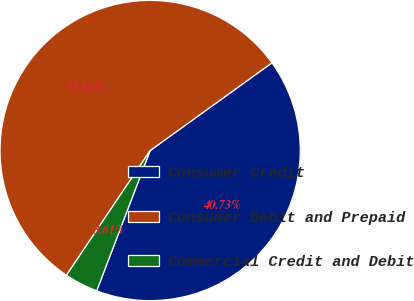Convert chart to OTSL. <chart><loc_0><loc_0><loc_500><loc_500><pie_chart><fcel>Consumer Credit<fcel>Consumer Debit and Prepaid<fcel>Commercial Credit and Debit<nl><fcel>40.73%<fcel>55.66%<fcel>3.61%<nl></chart> 